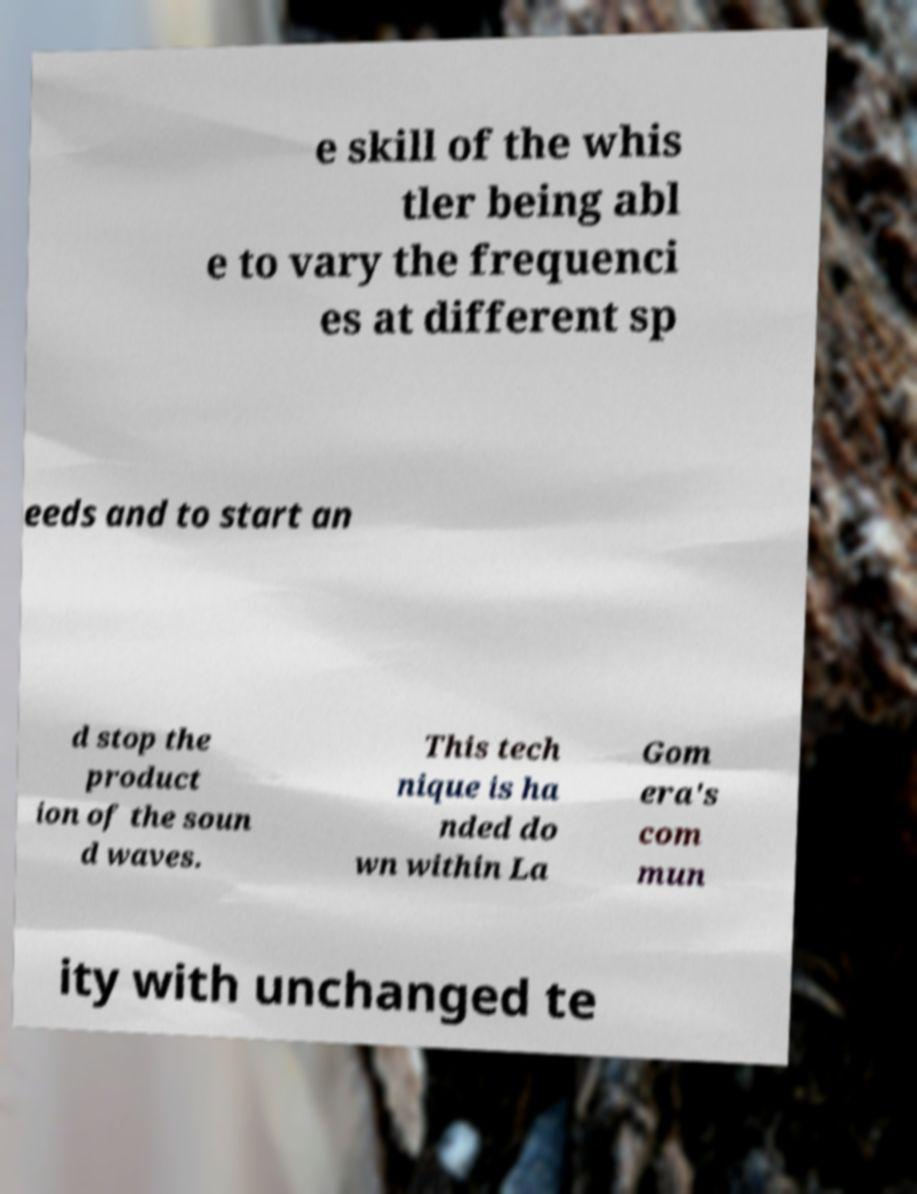What messages or text are displayed in this image? I need them in a readable, typed format. e skill of the whis tler being abl e to vary the frequenci es at different sp eeds and to start an d stop the product ion of the soun d waves. This tech nique is ha nded do wn within La Gom era's com mun ity with unchanged te 